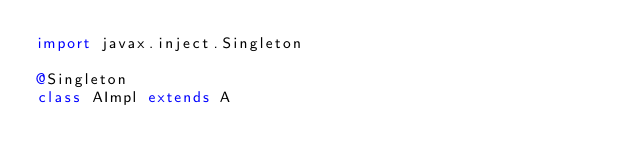Convert code to text. <code><loc_0><loc_0><loc_500><loc_500><_Scala_>import javax.inject.Singleton

@Singleton
class AImpl extends A</code> 